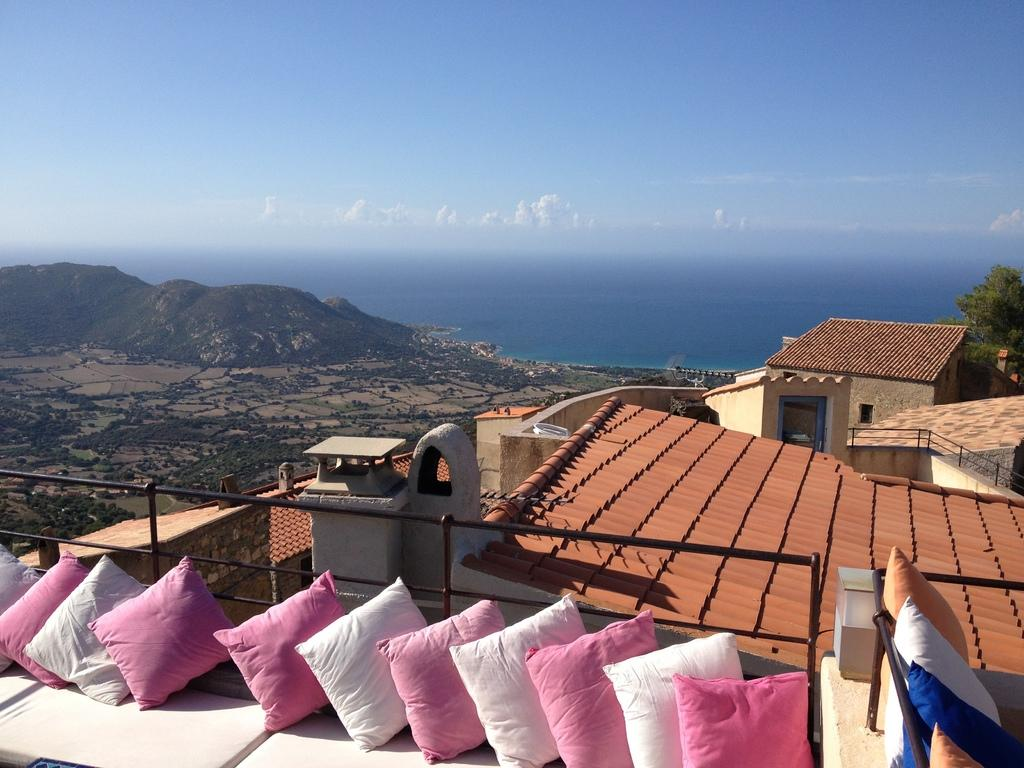What type of structures are in the image? There are buildings in the image. What can be seen behind the buildings? Trees are visible behind the buildings. What natural features are present in the background of the image? Mountains are present in the background of the image. What body of water is visible in the image? There is water visible in the image. What objects are at the bottom of the image? Pillows are at the bottom of the image. What is visible at the top of the image? The sky is visible at the top of the image. Can you tell me how many crows are sitting on the lawyer's head in the image? There is no lawyer or crow present in the image. What type of milk is being poured into the buildings in the image? There is no milk being poured into the buildings in the image; it is a landscape with buildings, trees, mountains, water, pillows, and sky. 